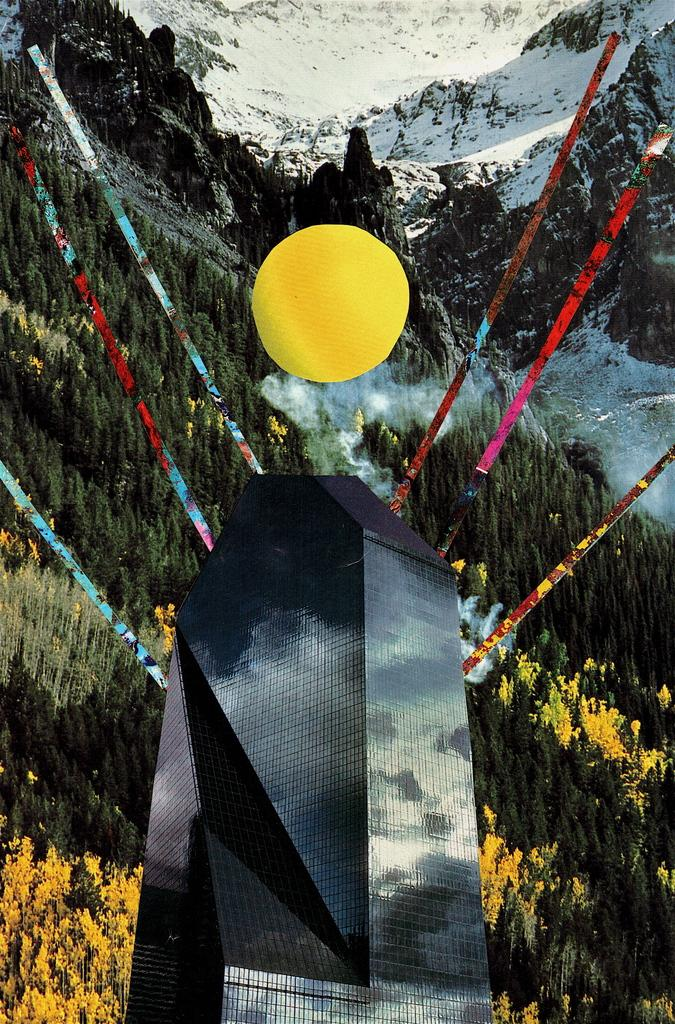What is the main structure in the image? There is a tower in the image. What additional object can be seen in the image? There is a balloon in the image. What type of natural elements are visible in the background of the image? There are flowers, trees, hills, and snow in the background of the image. Where is the shelf located in the image? There is no shelf present in the image. What type of seed can be seen growing near the tower in the image? There is no seed visible in the image; only the tower, balloon, and background elements are present. 